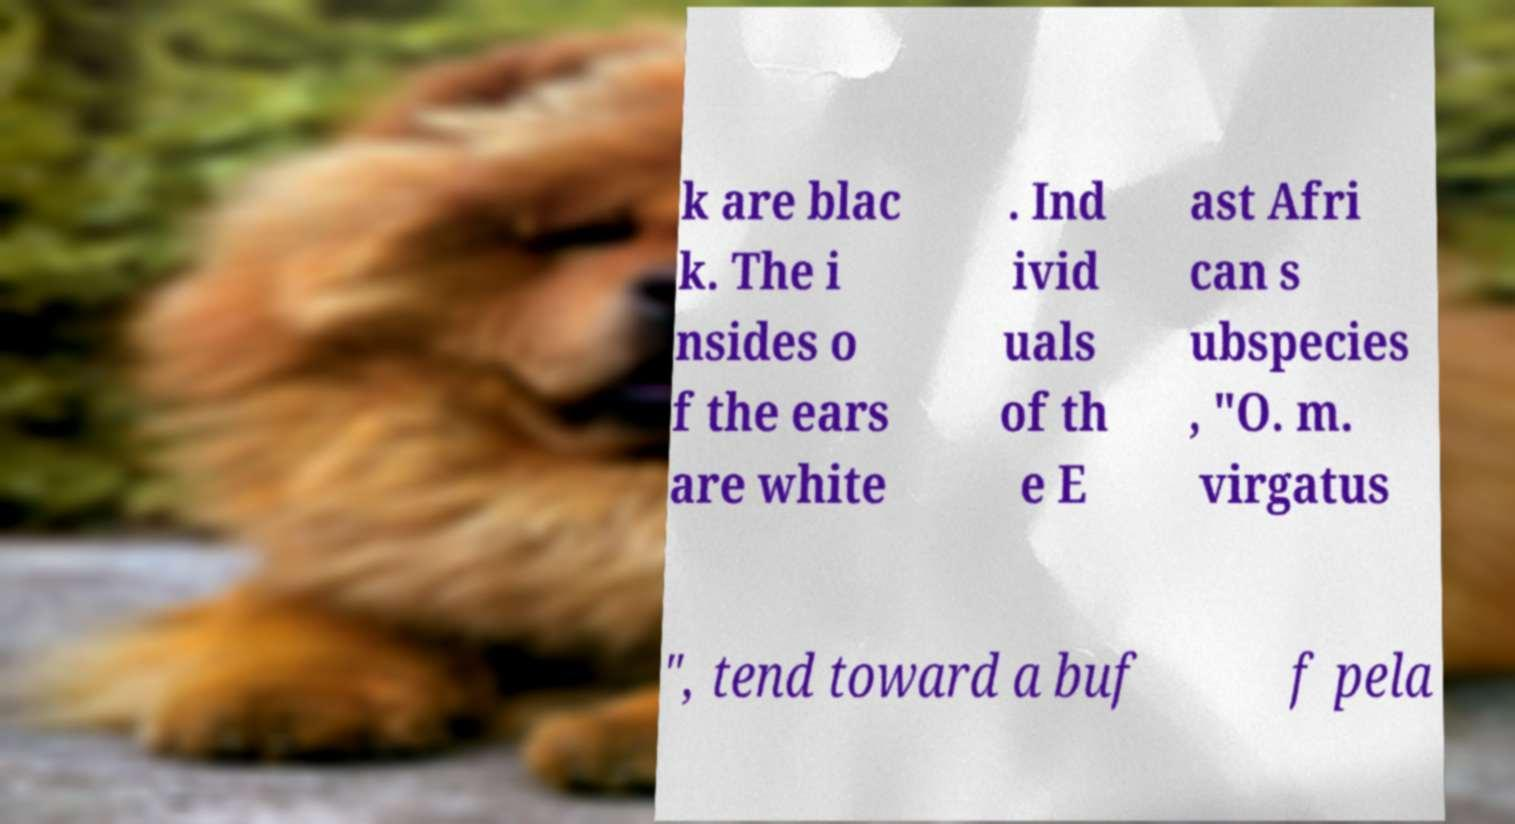Can you read and provide the text displayed in the image?This photo seems to have some interesting text. Can you extract and type it out for me? k are blac k. The i nsides o f the ears are white . Ind ivid uals of th e E ast Afri can s ubspecies , "O. m. virgatus ", tend toward a buf f pela 